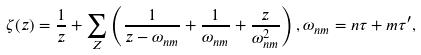<formula> <loc_0><loc_0><loc_500><loc_500>\zeta ( z ) = \frac { 1 } { z } + \sum _ { Z } \left ( \frac { 1 } { z - \omega _ { n m } } + \frac { 1 } { \omega _ { n m } } + \frac { z } { \omega _ { n m } ^ { 2 } } \right ) , \omega _ { n m } = n \tau + m \tau ^ { \prime } ,</formula> 